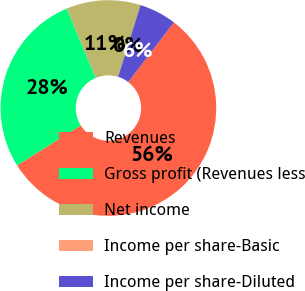<chart> <loc_0><loc_0><loc_500><loc_500><pie_chart><fcel>Revenues<fcel>Gross profit (Revenues less<fcel>Net income<fcel>Income per share-Basic<fcel>Income per share-Diluted<nl><fcel>55.69%<fcel>27.6%<fcel>11.14%<fcel>0.0%<fcel>5.57%<nl></chart> 